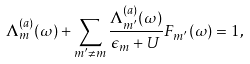Convert formula to latex. <formula><loc_0><loc_0><loc_500><loc_500>\Lambda _ { m } ^ { ( a ) } ( \omega ) + \sum _ { m ^ { \prime } \neq m } \frac { \Lambda _ { m ^ { \prime } } ^ { ( a ) } ( \omega ) } { \epsilon _ { m } + U } F _ { m ^ { \prime } } ( \omega ) = 1 ,</formula> 